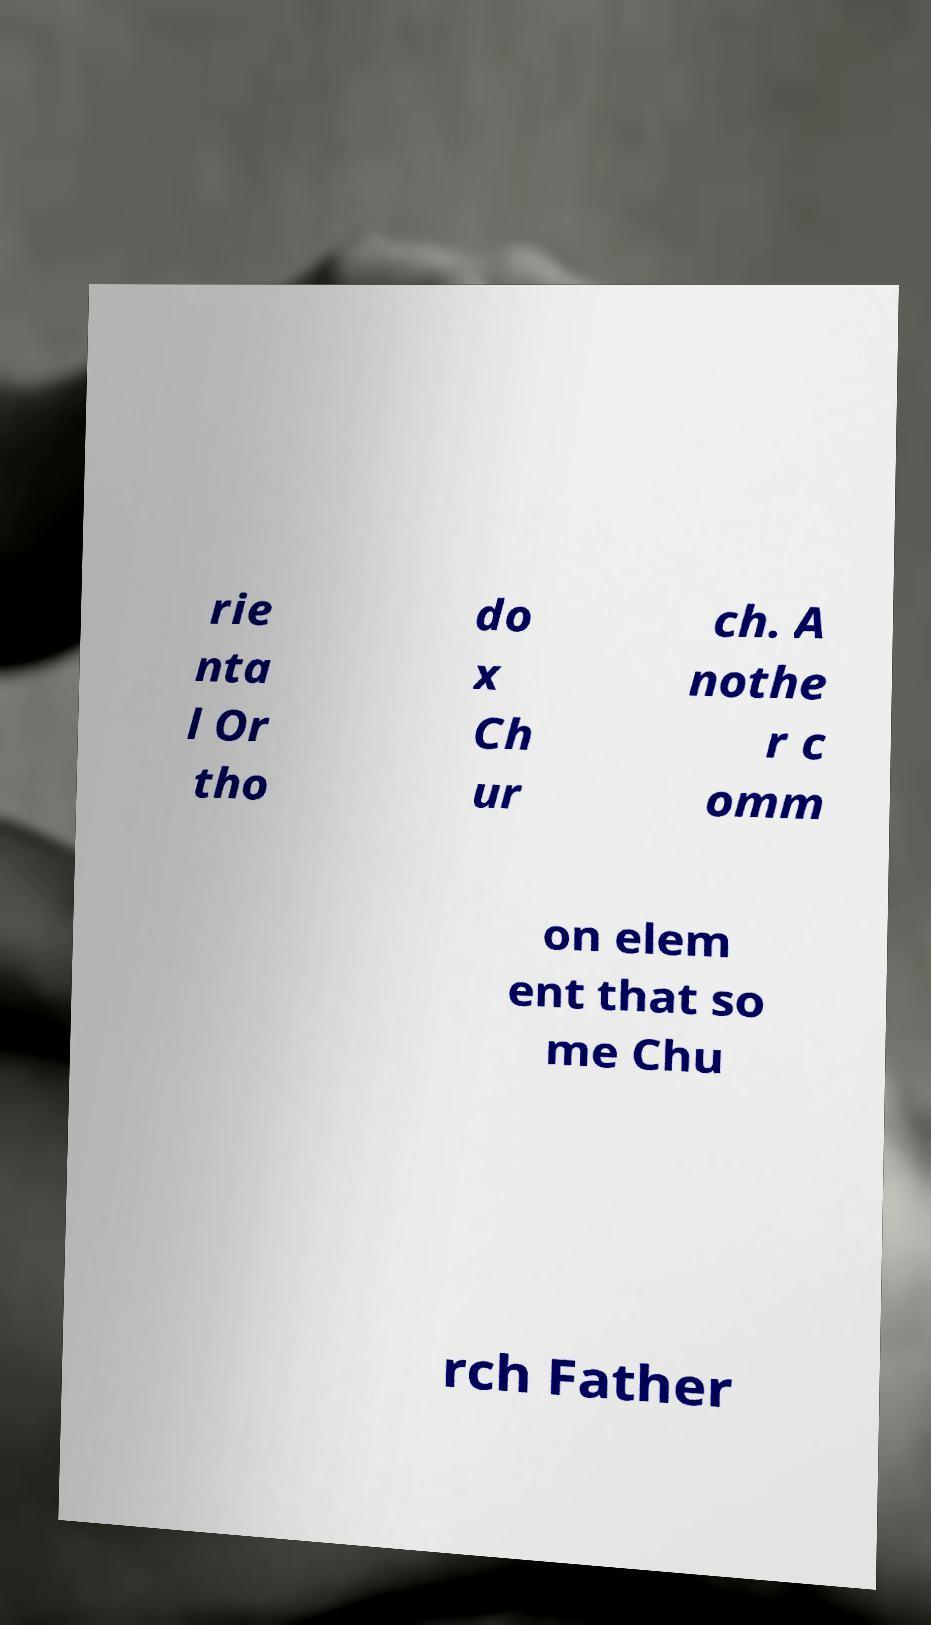What messages or text are displayed in this image? I need them in a readable, typed format. rie nta l Or tho do x Ch ur ch. A nothe r c omm on elem ent that so me Chu rch Father 